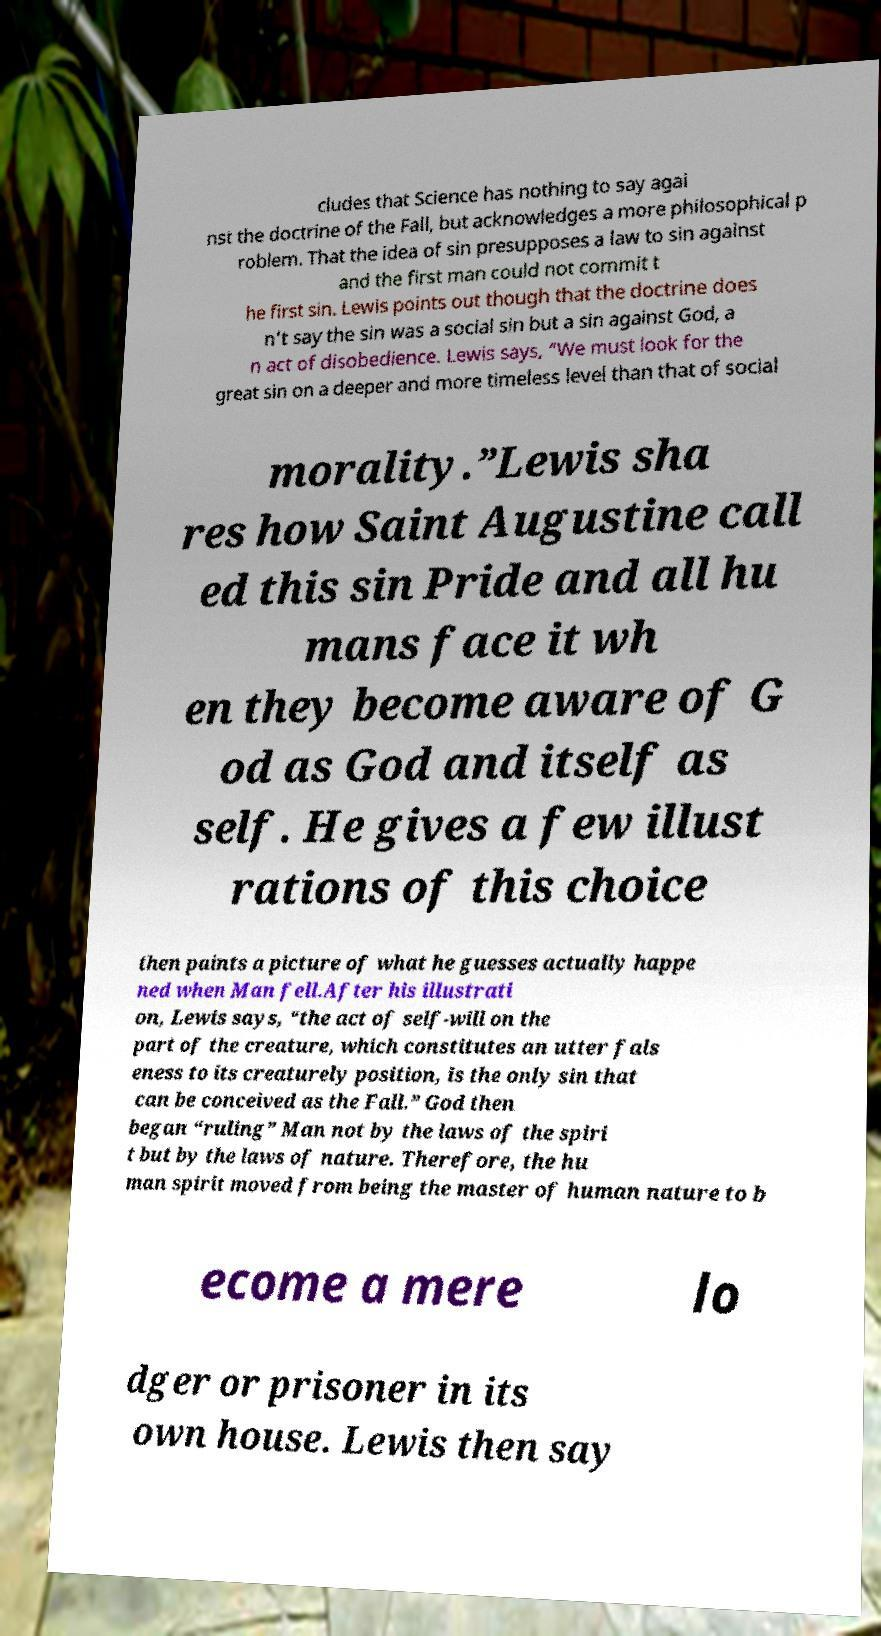Could you assist in decoding the text presented in this image and type it out clearly? cludes that Science has nothing to say agai nst the doctrine of the Fall, but acknowledges a more philosophical p roblem. That the idea of sin presupposes a law to sin against and the first man could not commit t he first sin. Lewis points out though that the doctrine does n’t say the sin was a social sin but a sin against God, a n act of disobedience. Lewis says, “We must look for the great sin on a deeper and more timeless level than that of social morality.”Lewis sha res how Saint Augustine call ed this sin Pride and all hu mans face it wh en they become aware of G od as God and itself as self. He gives a few illust rations of this choice then paints a picture of what he guesses actually happe ned when Man fell.After his illustrati on, Lewis says, “the act of self-will on the part of the creature, which constitutes an utter fals eness to its creaturely position, is the only sin that can be conceived as the Fall.” God then began “ruling” Man not by the laws of the spiri t but by the laws of nature. Therefore, the hu man spirit moved from being the master of human nature to b ecome a mere lo dger or prisoner in its own house. Lewis then say 